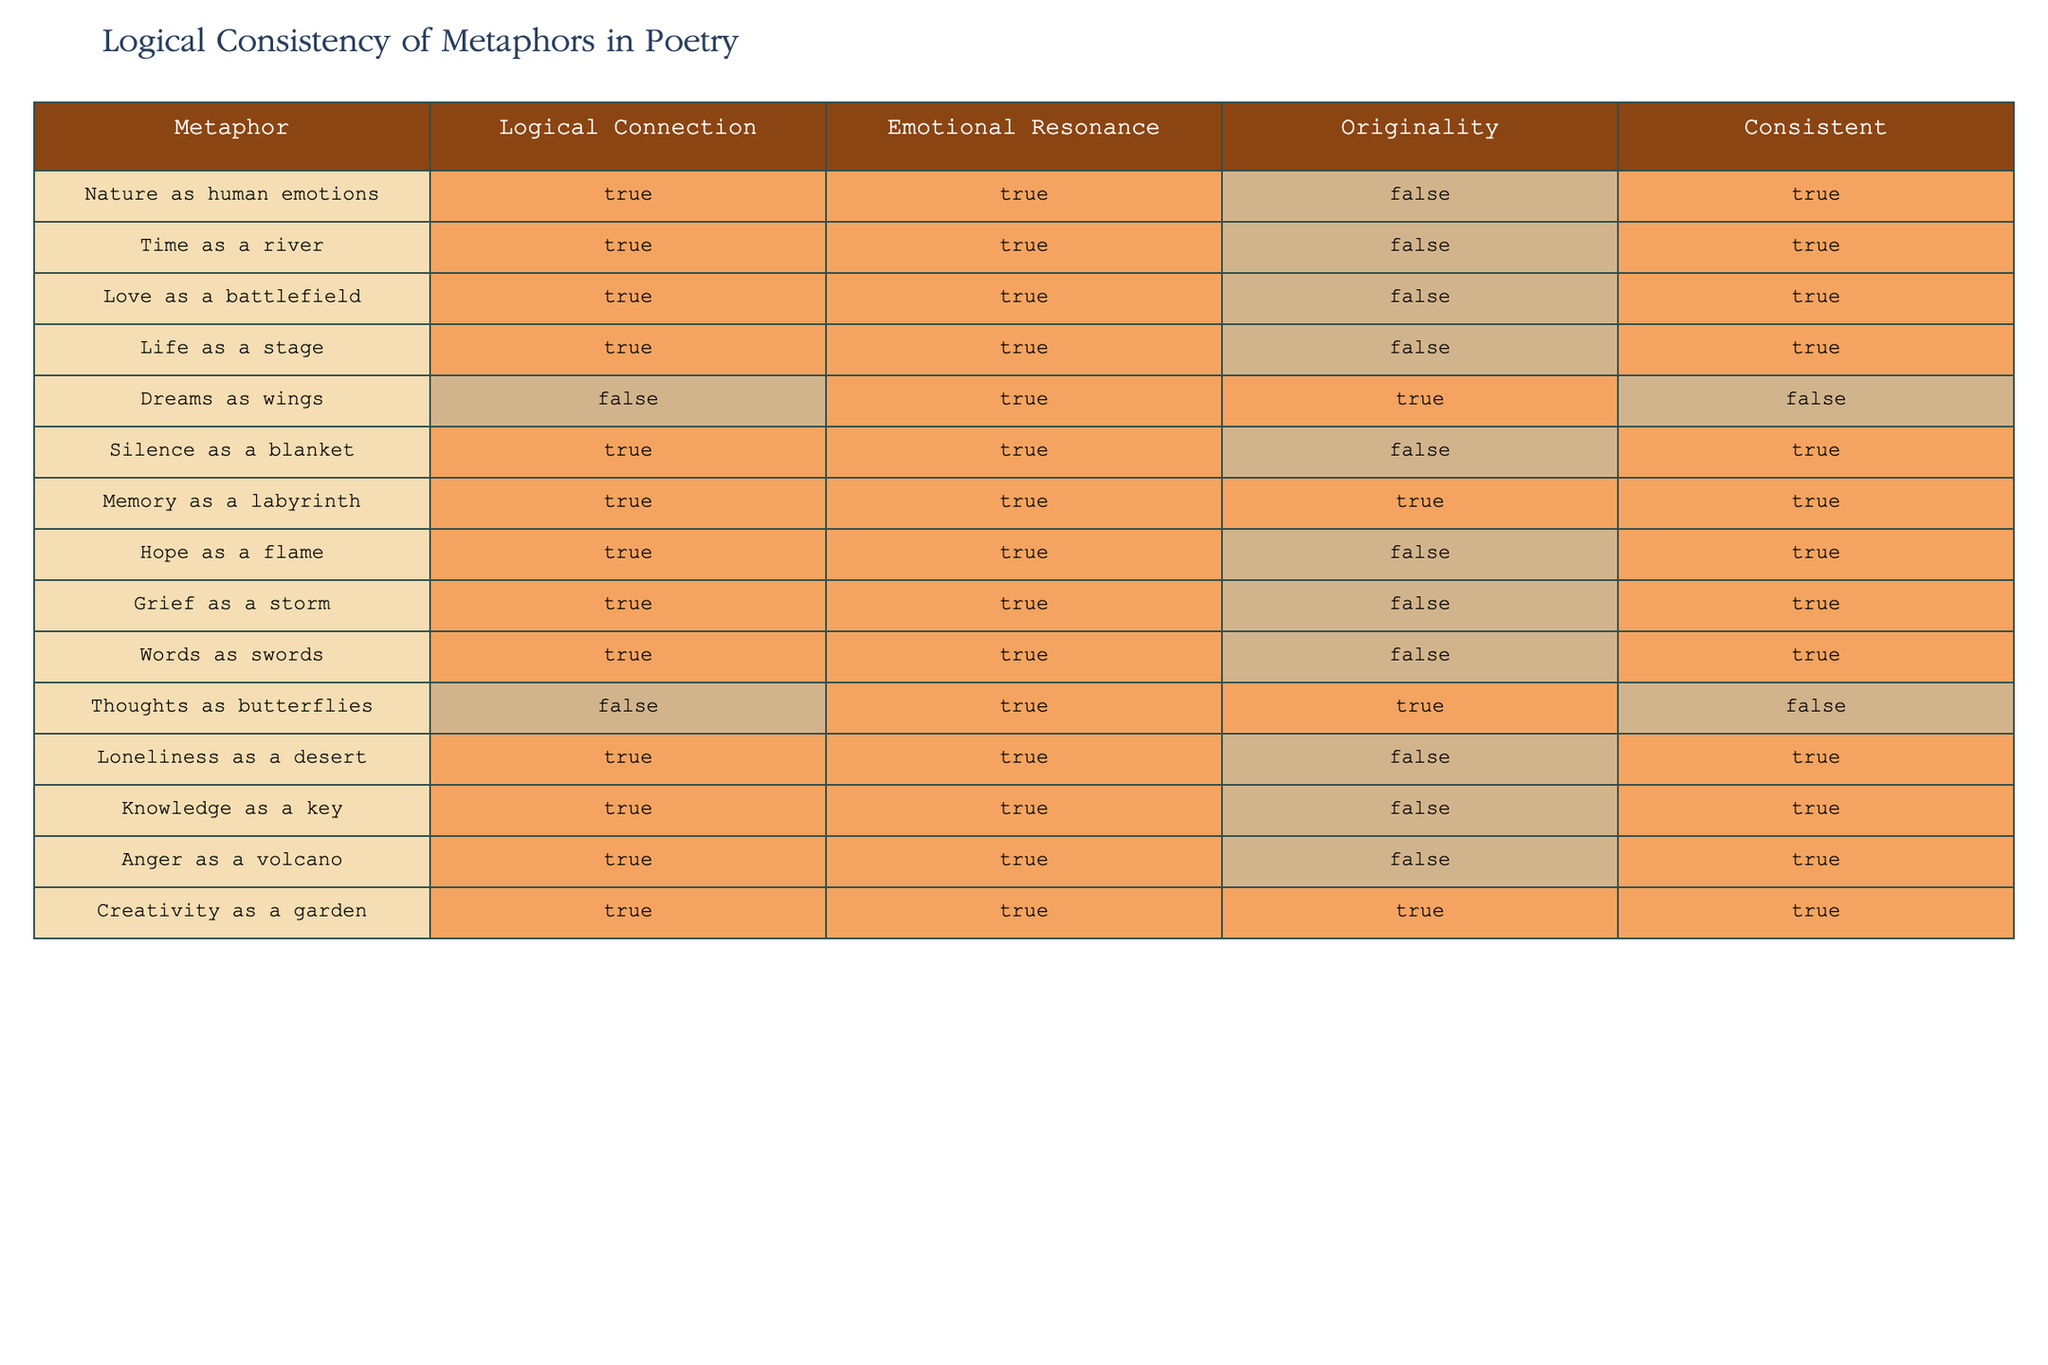What is the original metaphor that has the highest emotional resonance? The table indicates that 'Dreams as wings' has a true emotional resonance and an originality that is true as well. However, it is inconsistent due to its false logical connection. Other metaphors, such as 'Nature as human emotions', also have a true emotional resonance but lack originality; yet 'Memory as a labyrinth' has both high emotional resonance and originality. Therefore, 'Memory as a labyrinth' is the correct answer here.
Answer: Memory as a labyrinth How many metaphors are consistent with their logical connection? To find this, I will count the rows where the "Consistent" column is true. From the table, eight rows meet this criteria. Thus, the total count of metaphors consistent with their logical connection is eight.
Answer: 8 Is 'Time as a river' original? Referring to the table, 'Time as a river' has a false originality value, which directly indicates that it is not considered original. Hence, the answer is no.
Answer: No Which metaphor has the least emotional resonance but is highly original? Looking at metaphors with false logical connections and high originality values, the metaphor 'Thoughts as butterflies' is identified as it has true originality and a true emotional resonance. This leads to the conclusion that it does indeed meet the criteria of being consistent in emotional resonance and provides visual insight into the answer.
Answer: Thoughts as butterflies Are there more metaphors that are consistent than those that are not? By checking the rows that have 'Consistent' marked as true or false, I find that 8 metaphors are consistent, leaving 6 that are not. Thus, there are indeed more consistent metaphors than inconsistent ones.
Answer: Yes Which metaphor is both original and emotionally resonant? Analyzing the table, 'Creativity as a garden' is noted for its high originality and emotional resonance, which meets the criteria for both attributes in the same row. This is a direct observation from the table data.
Answer: Creativity as a garden What are the total number of metaphors that have a logical connection and are considered consistent? Examining the table, I notice there are eight metaphors marked 'true' for logical connection and consistent performance, effectively linking these two values for seven rows. Therefore, the total number adds up to eight.
Answer: 8 Is 'Anger as a volcano' emotionally resonant? In the data provided, the metaphor 'Anger as a volcano' indeed has a true value in emotional resonance, thereby confirming its emotional impact. Consequently, the response is yes.
Answer: Yes 